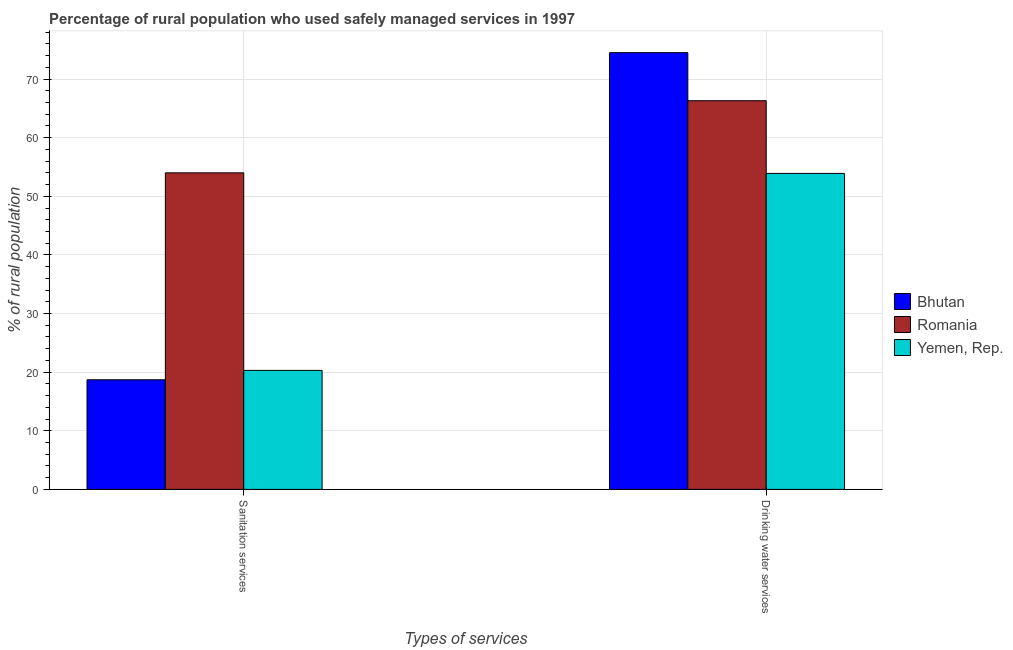How many different coloured bars are there?
Keep it short and to the point. 3. Are the number of bars per tick equal to the number of legend labels?
Provide a succinct answer. Yes. Are the number of bars on each tick of the X-axis equal?
Your response must be concise. Yes. How many bars are there on the 2nd tick from the right?
Your response must be concise. 3. What is the label of the 2nd group of bars from the left?
Provide a short and direct response. Drinking water services. What is the percentage of rural population who used drinking water services in Bhutan?
Offer a terse response. 74.5. Across all countries, what is the maximum percentage of rural population who used drinking water services?
Keep it short and to the point. 74.5. Across all countries, what is the minimum percentage of rural population who used drinking water services?
Keep it short and to the point. 53.9. In which country was the percentage of rural population who used sanitation services maximum?
Your answer should be very brief. Romania. In which country was the percentage of rural population who used sanitation services minimum?
Keep it short and to the point. Bhutan. What is the total percentage of rural population who used sanitation services in the graph?
Offer a terse response. 93. What is the difference between the percentage of rural population who used sanitation services in Yemen, Rep. and that in Bhutan?
Give a very brief answer. 1.6. What is the difference between the percentage of rural population who used sanitation services in Bhutan and the percentage of rural population who used drinking water services in Yemen, Rep.?
Make the answer very short. -35.2. What is the difference between the percentage of rural population who used drinking water services and percentage of rural population who used sanitation services in Romania?
Keep it short and to the point. 12.3. In how many countries, is the percentage of rural population who used drinking water services greater than 20 %?
Your answer should be compact. 3. What is the ratio of the percentage of rural population who used drinking water services in Bhutan to that in Yemen, Rep.?
Provide a short and direct response. 1.38. Is the percentage of rural population who used sanitation services in Bhutan less than that in Romania?
Your answer should be compact. Yes. In how many countries, is the percentage of rural population who used drinking water services greater than the average percentage of rural population who used drinking water services taken over all countries?
Your answer should be compact. 2. What does the 2nd bar from the left in Sanitation services represents?
Provide a short and direct response. Romania. What does the 1st bar from the right in Sanitation services represents?
Offer a very short reply. Yemen, Rep. What is the difference between two consecutive major ticks on the Y-axis?
Offer a terse response. 10. Does the graph contain any zero values?
Ensure brevity in your answer.  No. Does the graph contain grids?
Offer a very short reply. Yes. How many legend labels are there?
Make the answer very short. 3. How are the legend labels stacked?
Your answer should be very brief. Vertical. What is the title of the graph?
Keep it short and to the point. Percentage of rural population who used safely managed services in 1997. What is the label or title of the X-axis?
Your answer should be compact. Types of services. What is the label or title of the Y-axis?
Provide a short and direct response. % of rural population. What is the % of rural population of Romania in Sanitation services?
Your answer should be compact. 54. What is the % of rural population of Yemen, Rep. in Sanitation services?
Your response must be concise. 20.3. What is the % of rural population of Bhutan in Drinking water services?
Provide a succinct answer. 74.5. What is the % of rural population of Romania in Drinking water services?
Make the answer very short. 66.3. What is the % of rural population of Yemen, Rep. in Drinking water services?
Make the answer very short. 53.9. Across all Types of services, what is the maximum % of rural population in Bhutan?
Provide a short and direct response. 74.5. Across all Types of services, what is the maximum % of rural population of Romania?
Give a very brief answer. 66.3. Across all Types of services, what is the maximum % of rural population in Yemen, Rep.?
Provide a succinct answer. 53.9. Across all Types of services, what is the minimum % of rural population in Bhutan?
Give a very brief answer. 18.7. Across all Types of services, what is the minimum % of rural population in Yemen, Rep.?
Your answer should be very brief. 20.3. What is the total % of rural population in Bhutan in the graph?
Make the answer very short. 93.2. What is the total % of rural population in Romania in the graph?
Your response must be concise. 120.3. What is the total % of rural population of Yemen, Rep. in the graph?
Offer a very short reply. 74.2. What is the difference between the % of rural population of Bhutan in Sanitation services and that in Drinking water services?
Provide a short and direct response. -55.8. What is the difference between the % of rural population of Romania in Sanitation services and that in Drinking water services?
Your response must be concise. -12.3. What is the difference between the % of rural population of Yemen, Rep. in Sanitation services and that in Drinking water services?
Keep it short and to the point. -33.6. What is the difference between the % of rural population in Bhutan in Sanitation services and the % of rural population in Romania in Drinking water services?
Provide a short and direct response. -47.6. What is the difference between the % of rural population of Bhutan in Sanitation services and the % of rural population of Yemen, Rep. in Drinking water services?
Your answer should be compact. -35.2. What is the average % of rural population of Bhutan per Types of services?
Your answer should be compact. 46.6. What is the average % of rural population of Romania per Types of services?
Keep it short and to the point. 60.15. What is the average % of rural population of Yemen, Rep. per Types of services?
Your response must be concise. 37.1. What is the difference between the % of rural population in Bhutan and % of rural population in Romania in Sanitation services?
Make the answer very short. -35.3. What is the difference between the % of rural population in Romania and % of rural population in Yemen, Rep. in Sanitation services?
Offer a very short reply. 33.7. What is the difference between the % of rural population of Bhutan and % of rural population of Yemen, Rep. in Drinking water services?
Ensure brevity in your answer.  20.6. What is the ratio of the % of rural population in Bhutan in Sanitation services to that in Drinking water services?
Give a very brief answer. 0.25. What is the ratio of the % of rural population in Romania in Sanitation services to that in Drinking water services?
Offer a terse response. 0.81. What is the ratio of the % of rural population in Yemen, Rep. in Sanitation services to that in Drinking water services?
Ensure brevity in your answer.  0.38. What is the difference between the highest and the second highest % of rural population of Bhutan?
Your answer should be compact. 55.8. What is the difference between the highest and the second highest % of rural population in Romania?
Offer a terse response. 12.3. What is the difference between the highest and the second highest % of rural population of Yemen, Rep.?
Make the answer very short. 33.6. What is the difference between the highest and the lowest % of rural population of Bhutan?
Your answer should be very brief. 55.8. What is the difference between the highest and the lowest % of rural population of Romania?
Your answer should be compact. 12.3. What is the difference between the highest and the lowest % of rural population in Yemen, Rep.?
Provide a succinct answer. 33.6. 